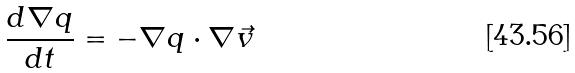Convert formula to latex. <formula><loc_0><loc_0><loc_500><loc_500>\frac { d \nabla q } { d t } = - \nabla q \cdot \nabla \vec { v }</formula> 